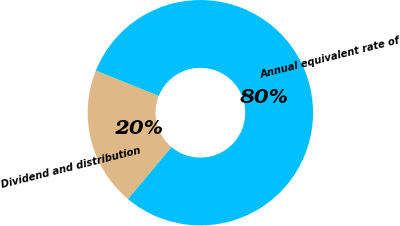Convert chart. <chart><loc_0><loc_0><loc_500><loc_500><pie_chart><fcel>Dividend and distribution<fcel>Annual equivalent rate of<nl><fcel>20.0%<fcel>80.0%<nl></chart> 